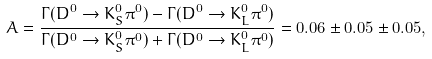Convert formula to latex. <formula><loc_0><loc_0><loc_500><loc_500>A = \frac { \Gamma ( D ^ { 0 } \rightarrow K ^ { 0 } _ { S } \pi ^ { 0 } ) - \Gamma ( D ^ { 0 } \rightarrow K ^ { 0 } _ { L } \pi ^ { 0 } ) } { \Gamma ( D ^ { 0 } \rightarrow K ^ { 0 } _ { S } \pi ^ { 0 } ) + \Gamma ( D ^ { 0 } \rightarrow K ^ { 0 } _ { L } \pi ^ { 0 } ) } = 0 . 0 6 \pm 0 . 0 5 \pm 0 . 0 5 ,</formula> 